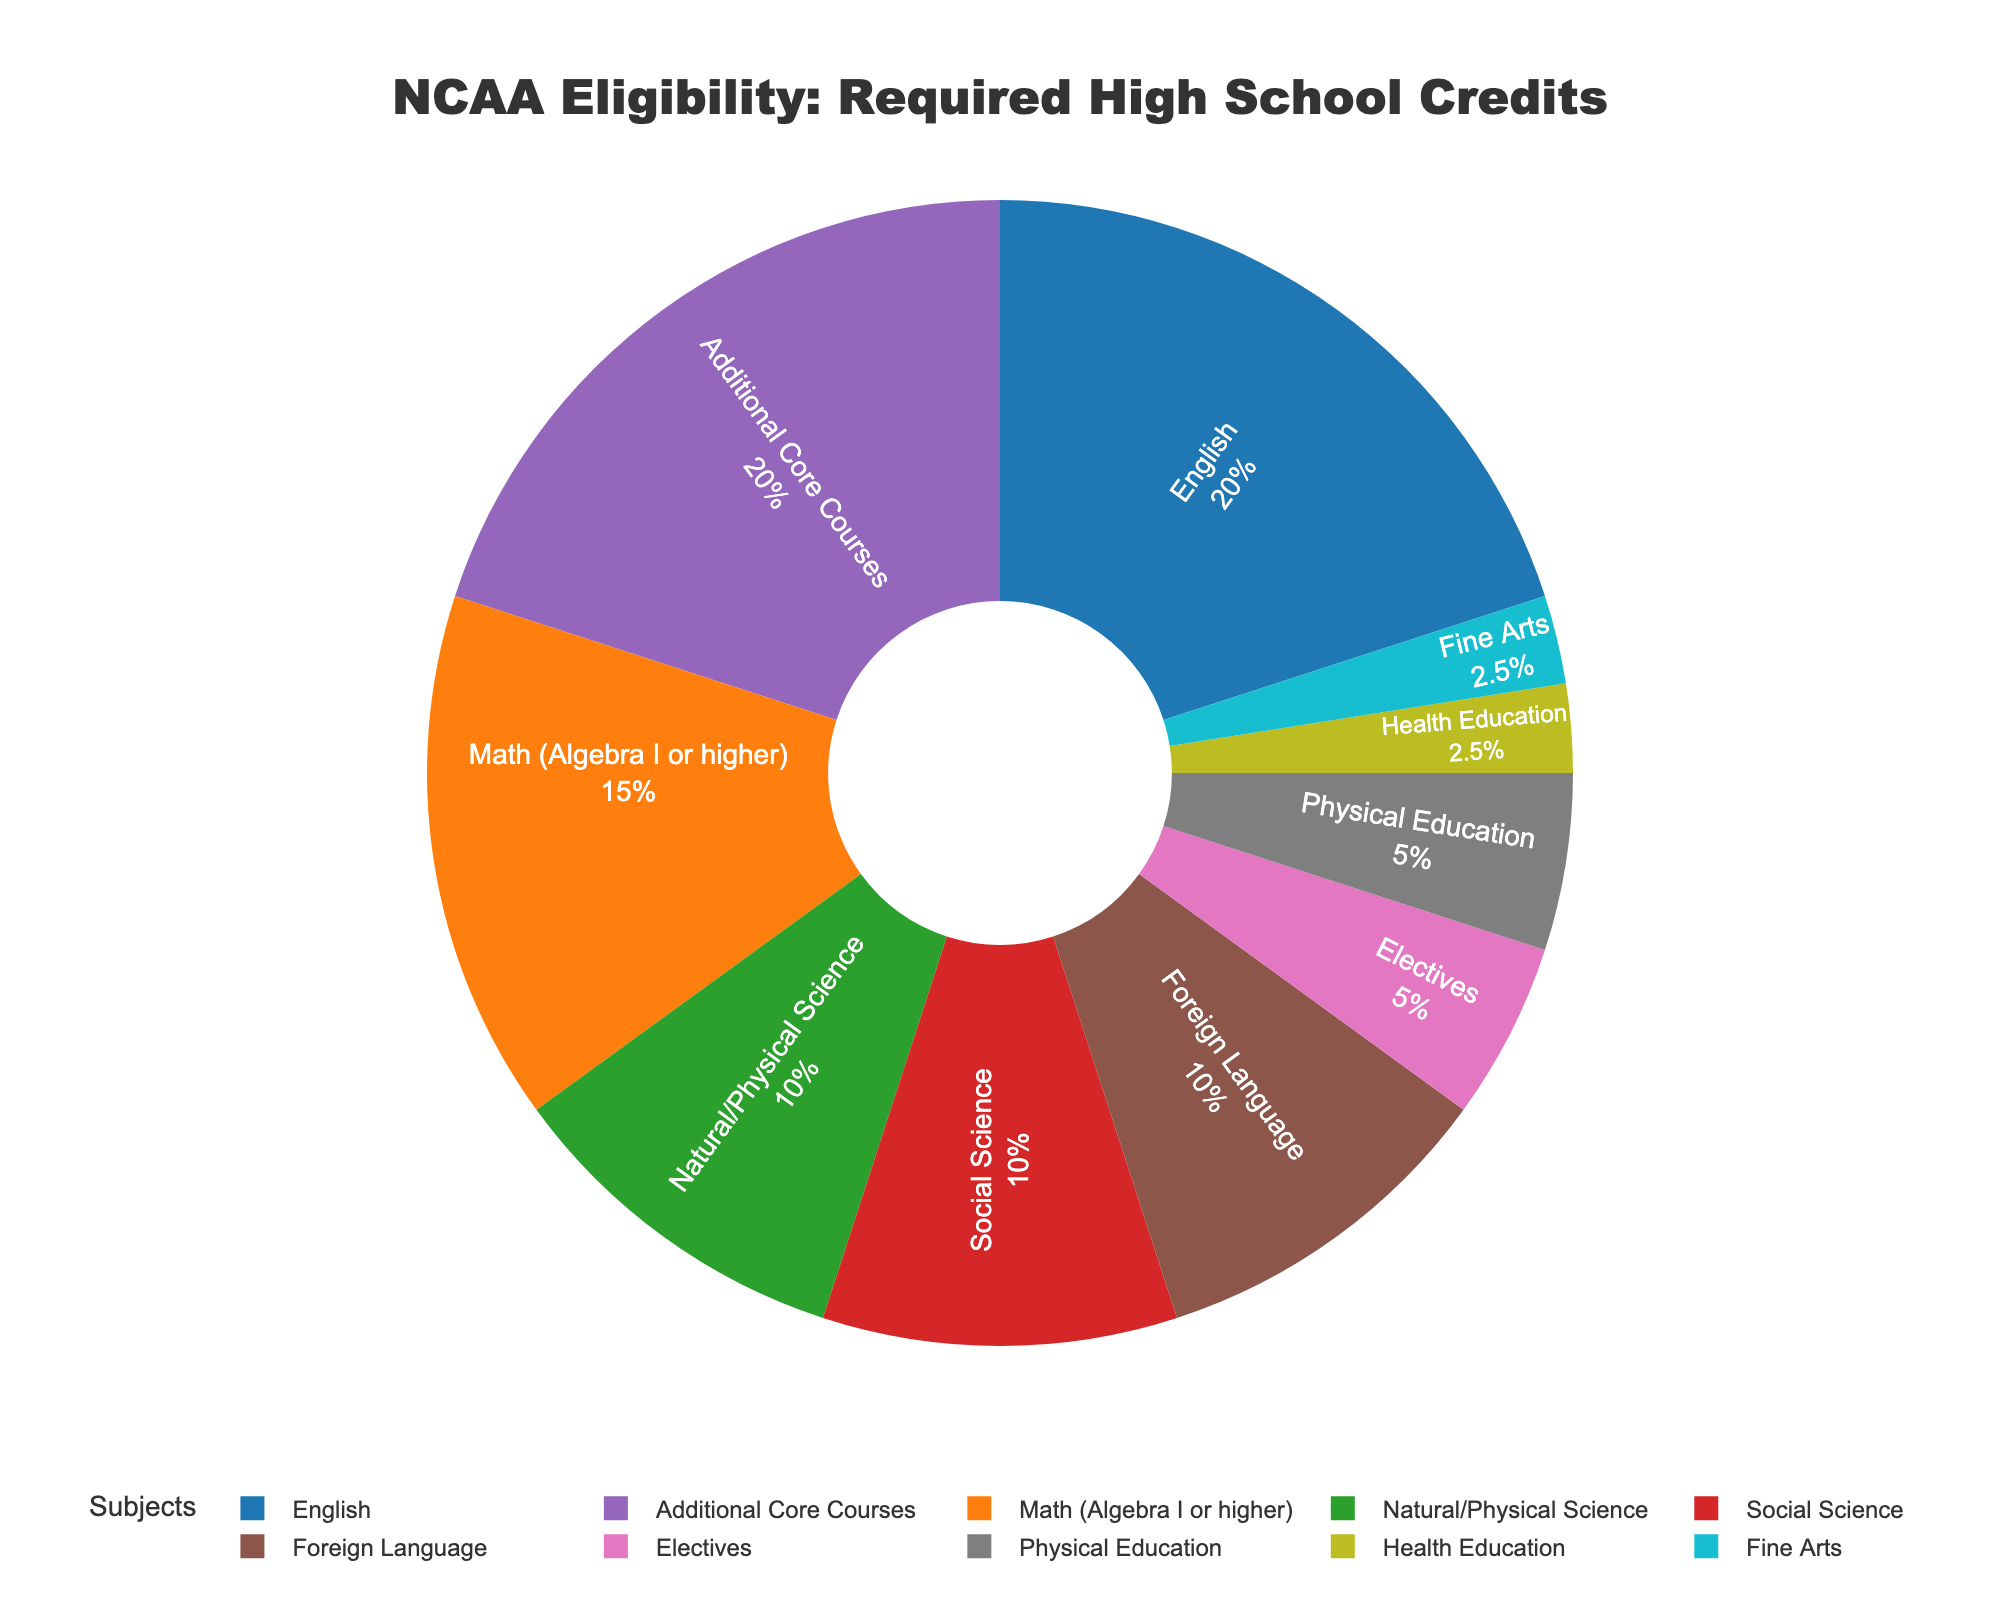What's the total number of credits required for NCAA eligibility? Sum all the required credits: 4 (English) + 3 (Math) + 2 (Natural/Physical Science) + 2 (Social Science) + 4 (Additional Core Courses) + 2 (Foreign Language) + 1 (Electives) + 1 (Physical Education) + 0.5 (Health Education) + 0.5 (Fine Arts) = 22
Answer: 22 Which subject requires the highest number of credits? Looking at the pie chart, the subject with the largest segment will have the highest number of required credits.
Answer: English How many subjects require exactly 2 credits each? Count all the segments representing subjects that have 2 credits each. These are Natural/Physical Science, Social Science, and Foreign Language.
Answer: 3 Compare the credits of English and Foreign Language. Which one requires more credits? Look at the segments for English and Foreign Language. English requires 4 credits, and Foreign Language requires 2 credits.
Answer: English What percentage of the total credits is from Additional Core Courses? Calculate the percentage by dividing the credits for Additional Core Courses by the total credits and multiplying by 100. (4 / 22) * 100 ≈ 18.18%
Answer: 18.18% Which subjects combined require the same amount of credits as English? Add the credits of subjects until they equal the credits for English: Natural/Physical Science (2) + Social Science (2) = 4, or Foreign Language (2) + Electives (1) + Fine Arts (0.5) + Health Education (0.5) = 4
Answer: Natural/Physical Science and Social Science or Foreign Language, Electives, Fine Arts, and Health Education Is the number of credits required for Physical Education more or less than the number required for Math? Compare the segment for Physical Education, which is 1 credit, to the segment for Math, which is 3 credits.
Answer: Less What is the combined percentage of credits for Fine Arts and Health Education? Add the percentage values of Fine Arts and Health Education segments: 0.5 credits each out of 22 credits total. [(0.5 + 0.5) / 22] * 100 ≈ 4.55%
Answer: 4.55% Are there more required credits in total for core subjects (English, Math, Natural/Physical Science, Social Science) or non-core subjects (everything else)? Sum the core subjects' credits: 4 (English) + 3 (Math) + 2 (Natural/Physical Science) + 2 (Social Science) = 11. Sum the non-core subjects' credits: 22 - 11 = 11.
Answer: Equal 